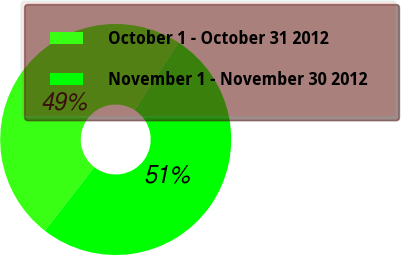Convert chart. <chart><loc_0><loc_0><loc_500><loc_500><pie_chart><fcel>October 1 - October 31 2012<fcel>November 1 - November 30 2012<nl><fcel>48.62%<fcel>51.38%<nl></chart> 